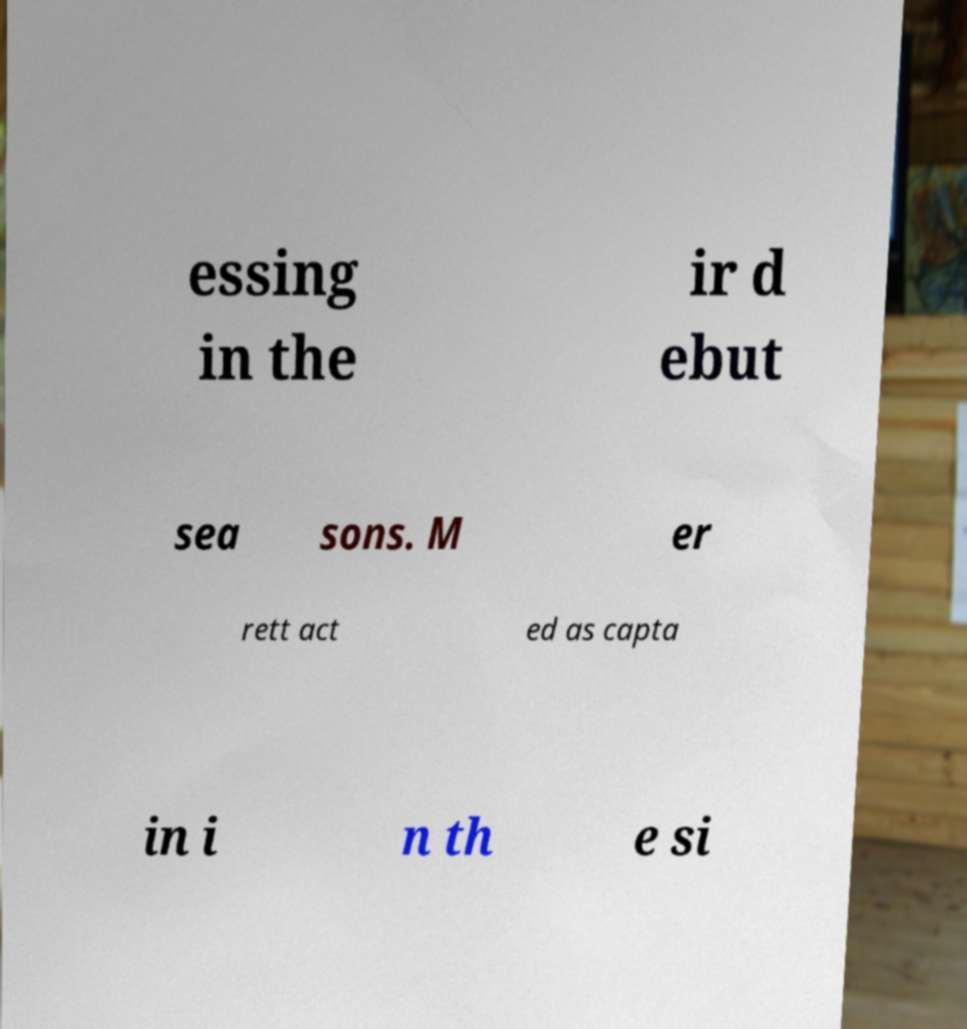For documentation purposes, I need the text within this image transcribed. Could you provide that? essing in the ir d ebut sea sons. M er rett act ed as capta in i n th e si 